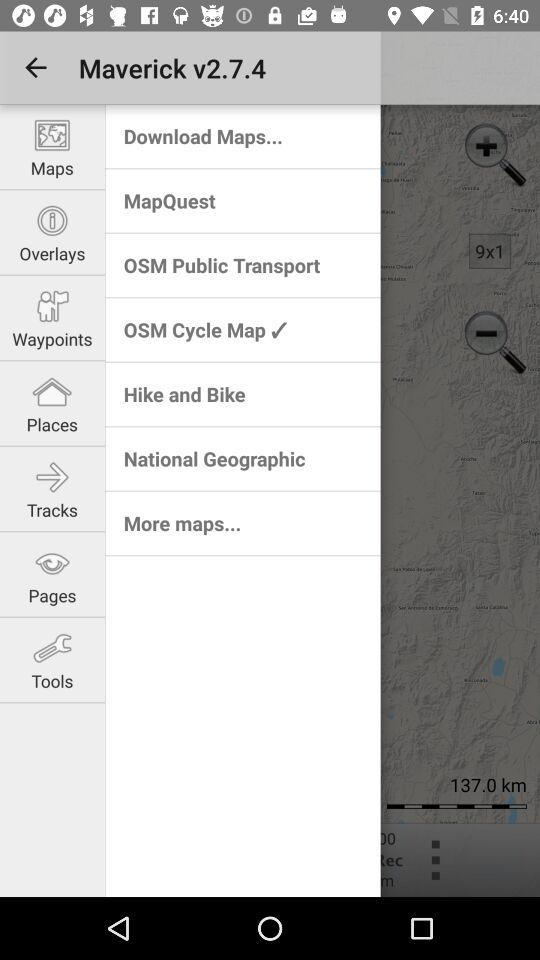What version is used? The version is 2.7.4. 